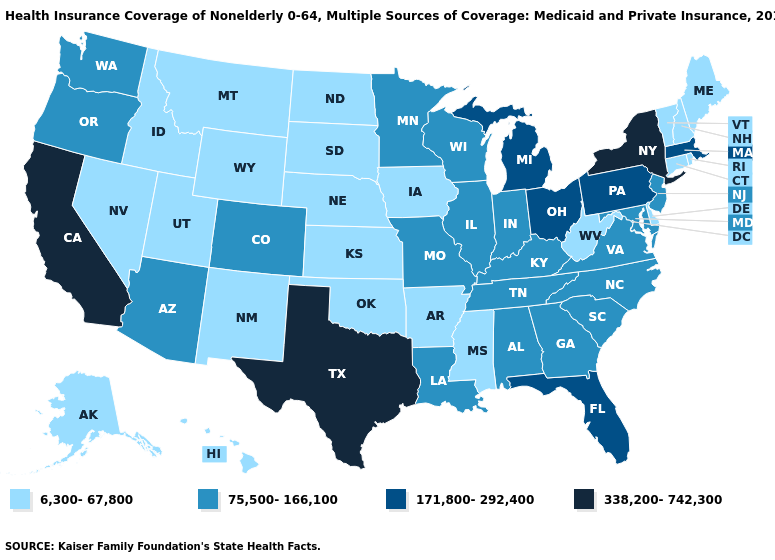How many symbols are there in the legend?
Be succinct. 4. Does Maine have the lowest value in the USA?
Answer briefly. Yes. Does Mississippi have the lowest value in the USA?
Be succinct. Yes. Does Arkansas have the lowest value in the USA?
Write a very short answer. Yes. What is the lowest value in states that border Montana?
Write a very short answer. 6,300-67,800. Does Missouri have a lower value than Oklahoma?
Give a very brief answer. No. Name the states that have a value in the range 6,300-67,800?
Concise answer only. Alaska, Arkansas, Connecticut, Delaware, Hawaii, Idaho, Iowa, Kansas, Maine, Mississippi, Montana, Nebraska, Nevada, New Hampshire, New Mexico, North Dakota, Oklahoma, Rhode Island, South Dakota, Utah, Vermont, West Virginia, Wyoming. Among the states that border Iowa , which have the lowest value?
Write a very short answer. Nebraska, South Dakota. What is the value of New Mexico?
Concise answer only. 6,300-67,800. Does the map have missing data?
Answer briefly. No. What is the value of Connecticut?
Answer briefly. 6,300-67,800. Among the states that border Illinois , which have the lowest value?
Keep it brief. Iowa. What is the value of Colorado?
Short answer required. 75,500-166,100. Among the states that border Texas , which have the lowest value?
Answer briefly. Arkansas, New Mexico, Oklahoma. 